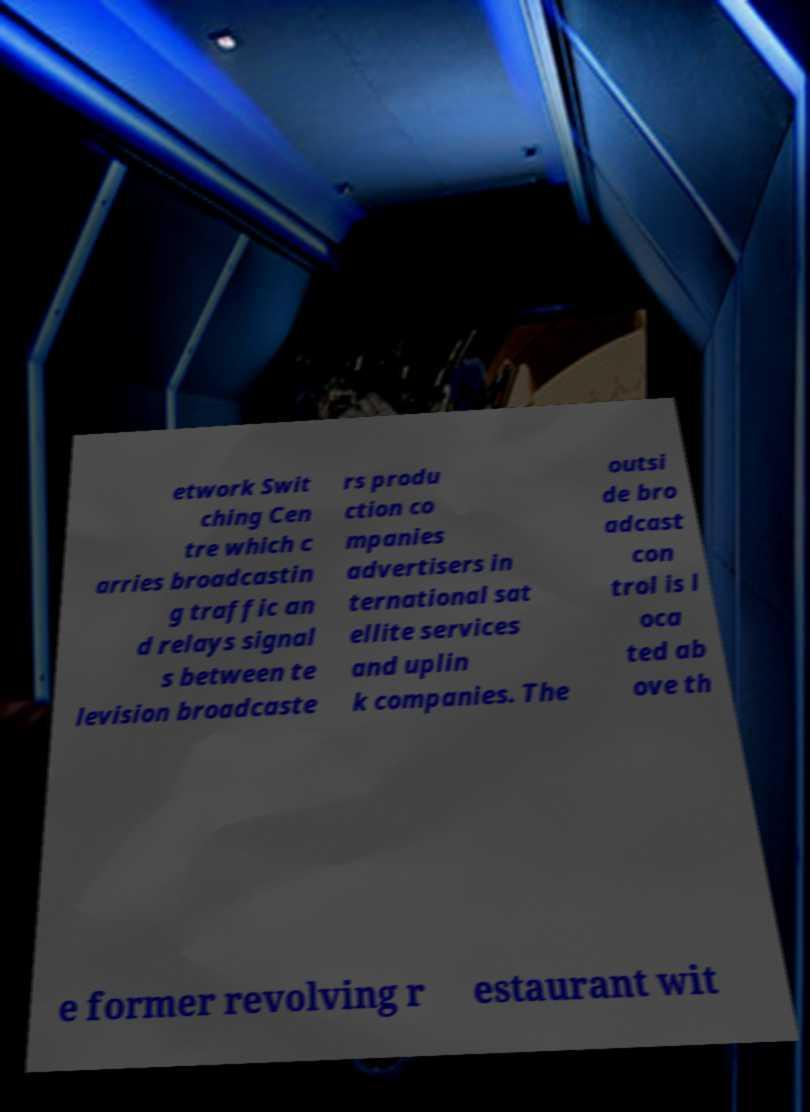Can you accurately transcribe the text from the provided image for me? etwork Swit ching Cen tre which c arries broadcastin g traffic an d relays signal s between te levision broadcaste rs produ ction co mpanies advertisers in ternational sat ellite services and uplin k companies. The outsi de bro adcast con trol is l oca ted ab ove th e former revolving r estaurant wit 